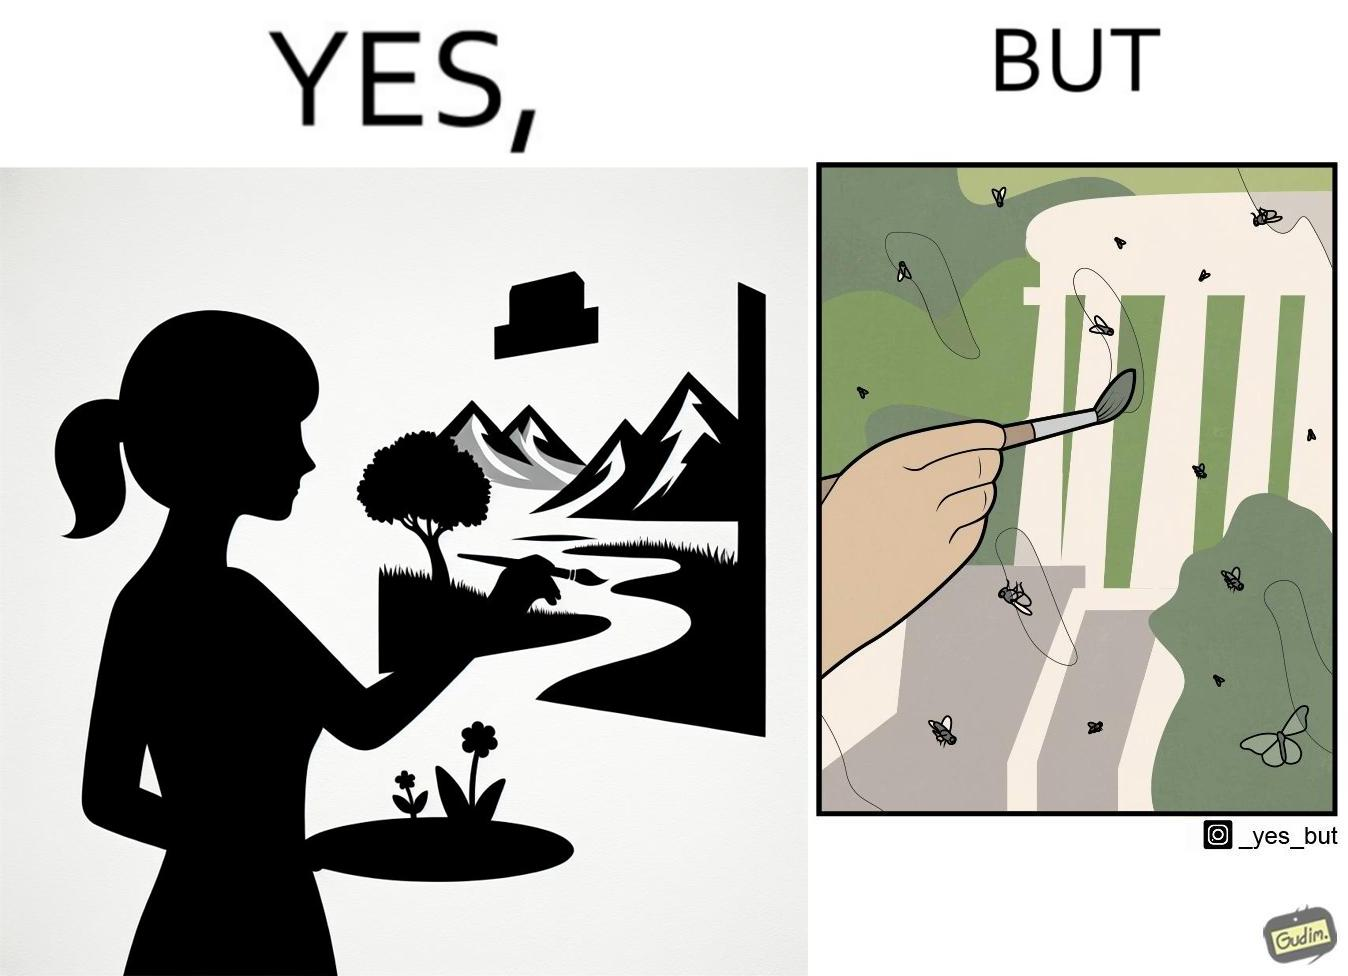What does this image depict? The images are funny since they show how a peaceful sight like a woman painting a natural scenery looks good only from afar. When looked closely we can see details like flies on the painting which make us uneasy and the scene is not so good to look at anymore. 